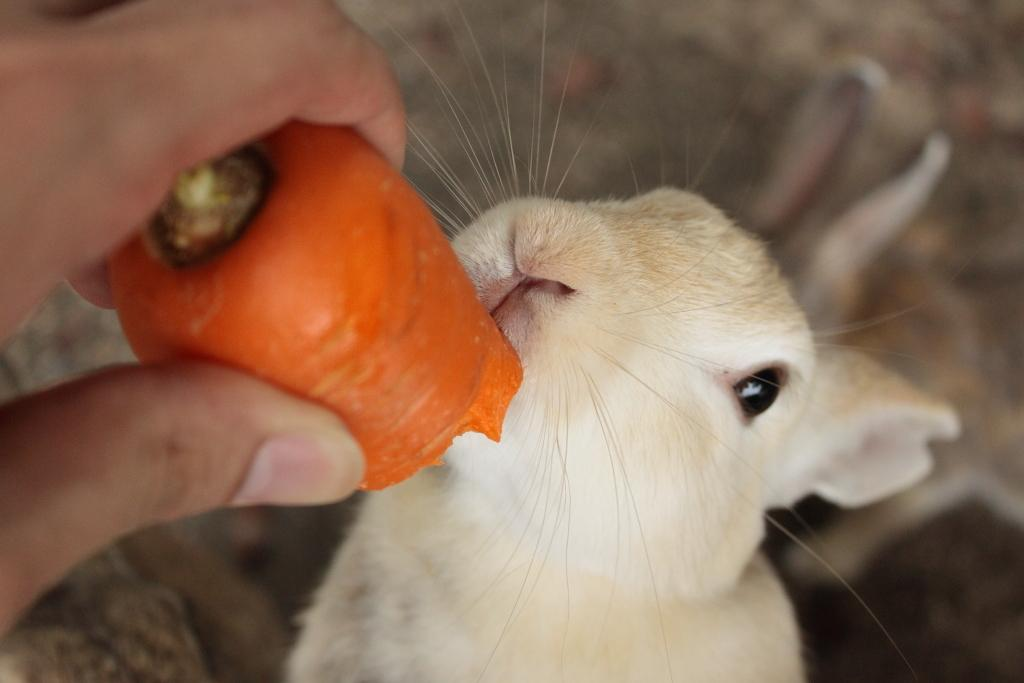Who or what is the main subject in the image? There is a person in the image. What is the person holding in the image? The person is holding a carrot. What other animal or creature is present in the image? There is a rabbit in the image. Can you describe the appearance of the rabbit? The rabbit is white and cream colored. How would you describe the background of the image? The background of the image is blurred. Where is the chalk located in the image? There is no chalk present in the image. What type of desk can be seen in the image? There is no desk present in the image. 